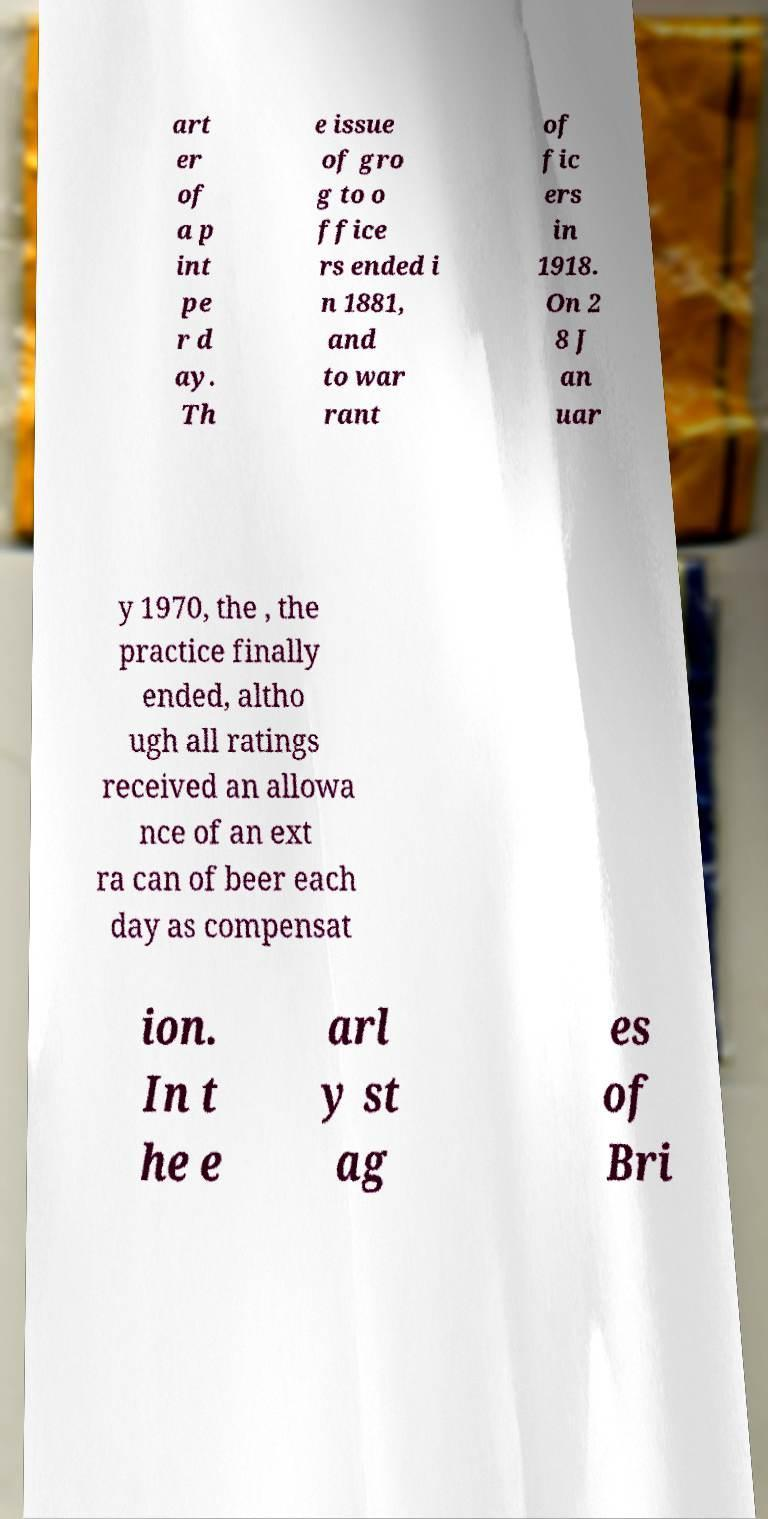Could you extract and type out the text from this image? art er of a p int pe r d ay. Th e issue of gro g to o ffice rs ended i n 1881, and to war rant of fic ers in 1918. On 2 8 J an uar y 1970, the , the practice finally ended, altho ugh all ratings received an allowa nce of an ext ra can of beer each day as compensat ion. In t he e arl y st ag es of Bri 